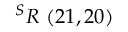<formula> <loc_0><loc_0><loc_500><loc_500>^ { S } R \ ( 2 1 , 2 0 )</formula> 